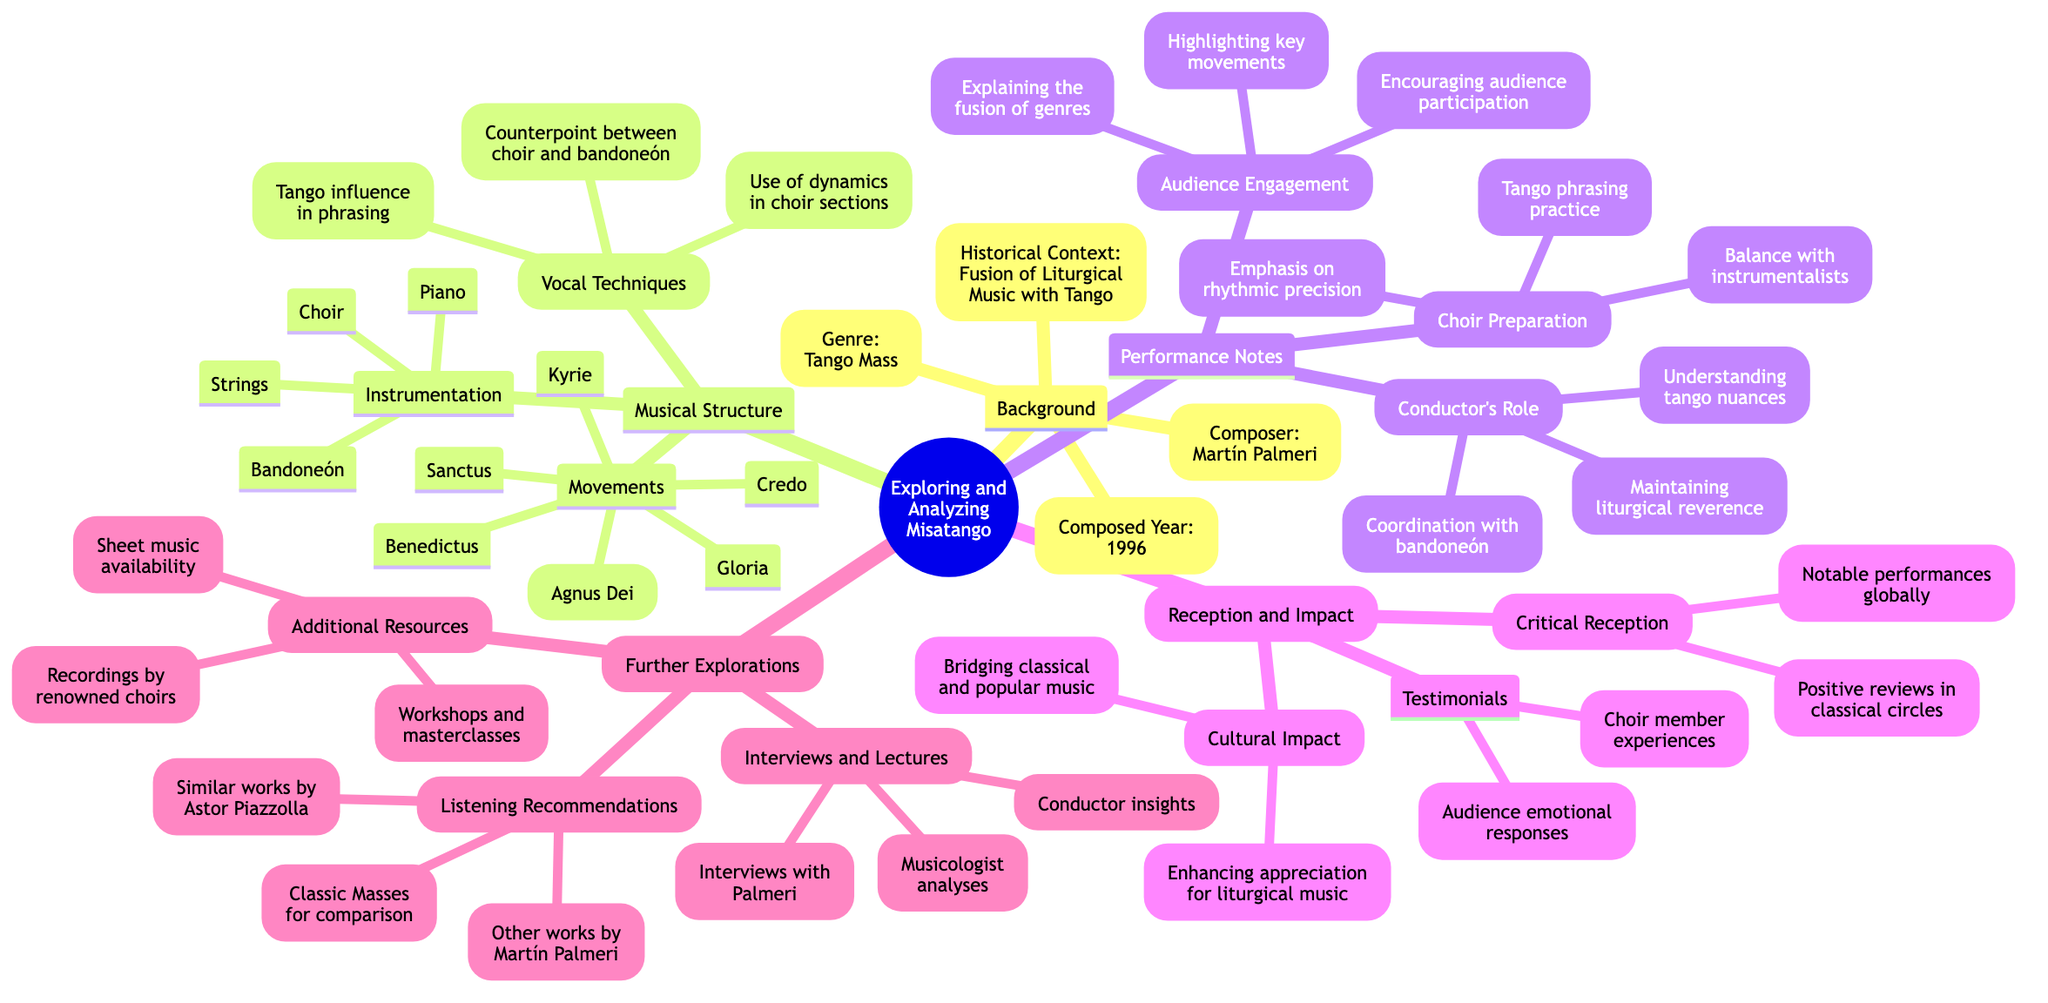What is the composer of Misatango? The diagram lists "Martín Palmeri" under the Background section as the composer of Misatango.
Answer: Martín Palmeri In what year was Misatango composed? The diagram indicates the "Composed Year" as "1996" in the Background section.
Answer: 1996 How many movements are there in Misatango? The diagram shows a list of six movements under the Musical Structure section; by counting the items, one can find there are six.
Answer: 6 What is one instrumental component used in Misatango? The Instrumentation section of the diagram includes "Bandoneón" as one of the components used, which can be picked out from the list.
Answer: Bandoneón What is a focus area for choir preparation according to the diagram? The diagram lists "Tango phrasing practice," under the Choir Preparation section as a focus area for the choir's preparation.
Answer: Tango phrasing practice Which section highlights audience engagement strategies? The diagram specifies "Audience Engagement" as the title of a section focused on strategies for engaging the audience while performing.
Answer: Audience Engagement What is the cultural impact of Misatango mentioned in the diagram? The diagram states that it "Bridging classical and popular music" is a cultural impact of Misatango, which can be found under the Cultural Impact sub-section.
Answer: Bridging classical and popular music How many listening recommendations are provided for further exploration? The Listening Recommendations section lists three items, which can be counted directly from that list.
Answer: 3 Which section addresses the conductor's role? The diagram clearly states "Conductor's Role" as a specific section within the Performance Notes, highlighting its importance in the context of the performance.
Answer: Conductor's Role 